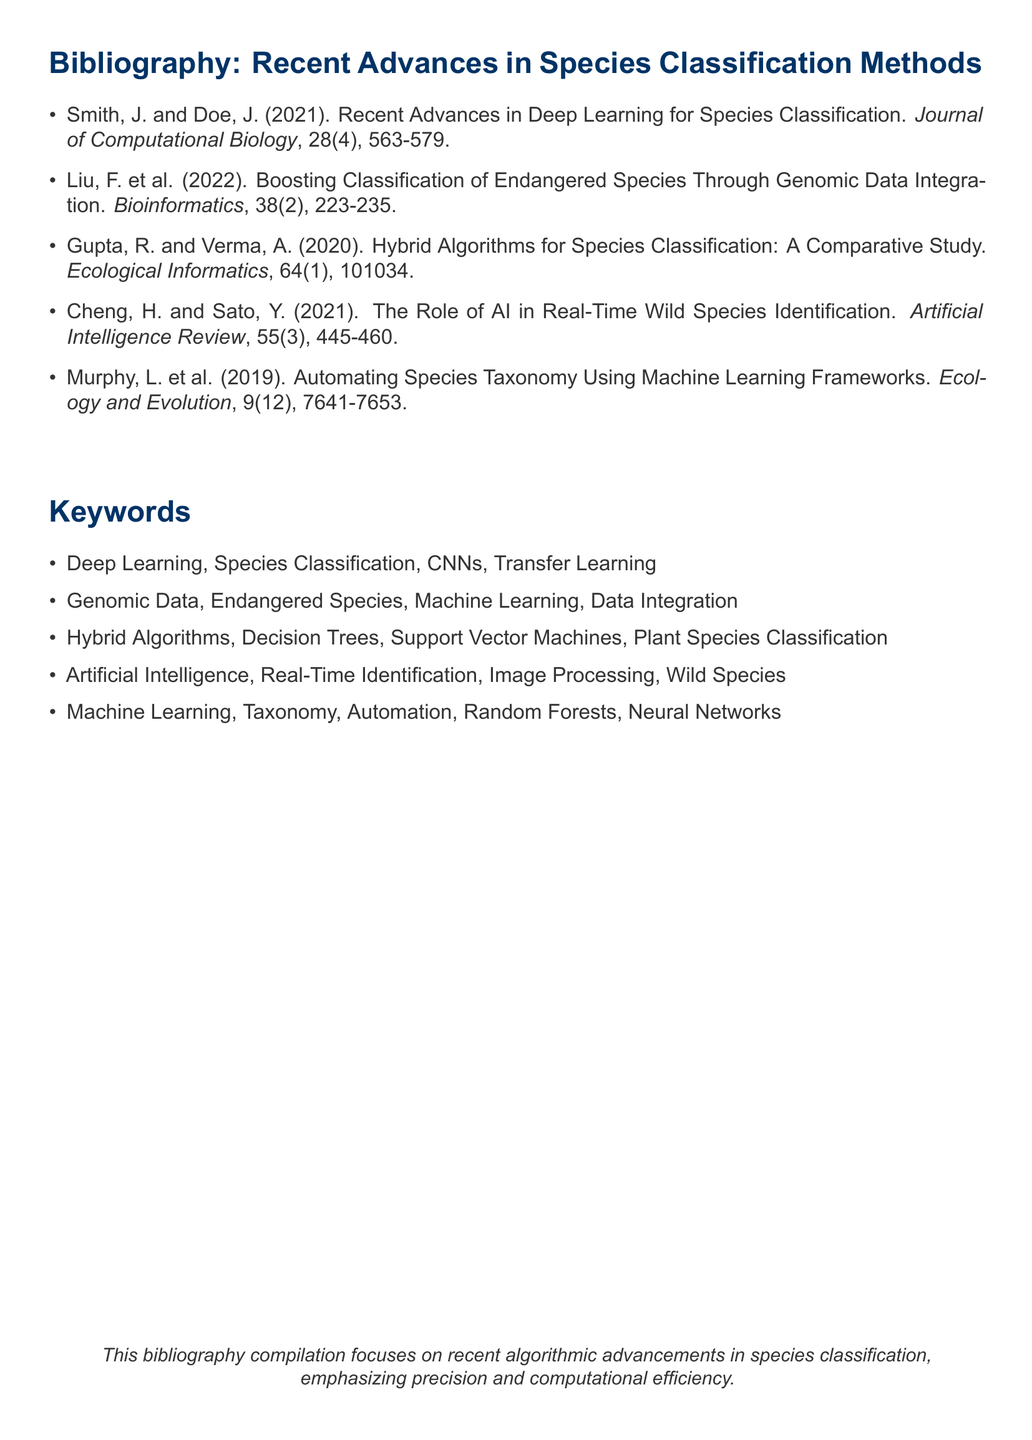What is the title of the first listed paper? The title is found in the first entry of the bibliography, and it reads: “Recent Advances in Deep Learning for Species Classification.”
Answer: Recent Advances in Deep Learning for Species Classification Who are the authors of the paper published in 2022? The 2022 paper is authored by Liu, F. et al., as noted in the entry for that year.
Answer: Liu, F. et al In which journal was the comparative study published? This information can be found in the citation for Gupta and Verma's work, which specifies the journal’s name.
Answer: Ecological Informatics How many papers were published in 2021? The document lists two papers with publication years noted as 2021.
Answer: 2 What is one keyword that relates to artificial intelligence according to the document? The keywords section includes various terms, and "Artificial Intelligence" is one as listed.
Answer: Artificial Intelligence What is the focus of this bibliography compilation? This is detailed in the concluding sentence, indicating a focus on advances in species classification.
Answer: Recent algorithmic advancements in species classification Which classification method is mentioned along with "Neural Networks"? The keywords section contains "Machine Learning" listed directly alongside "Neural Networks."
Answer: Machine Learning How many authors contributed to the paper on automating species taxonomy? The document notes that the authorship includes "L. Murphy et al." which indicates multiple authors.
Answer: L. Murphy et al What publication year is associated with the article on genomic data integration? The publication year for Liu et al.'s article regarding genomic data integration is specified in the citation.
Answer: 2022 